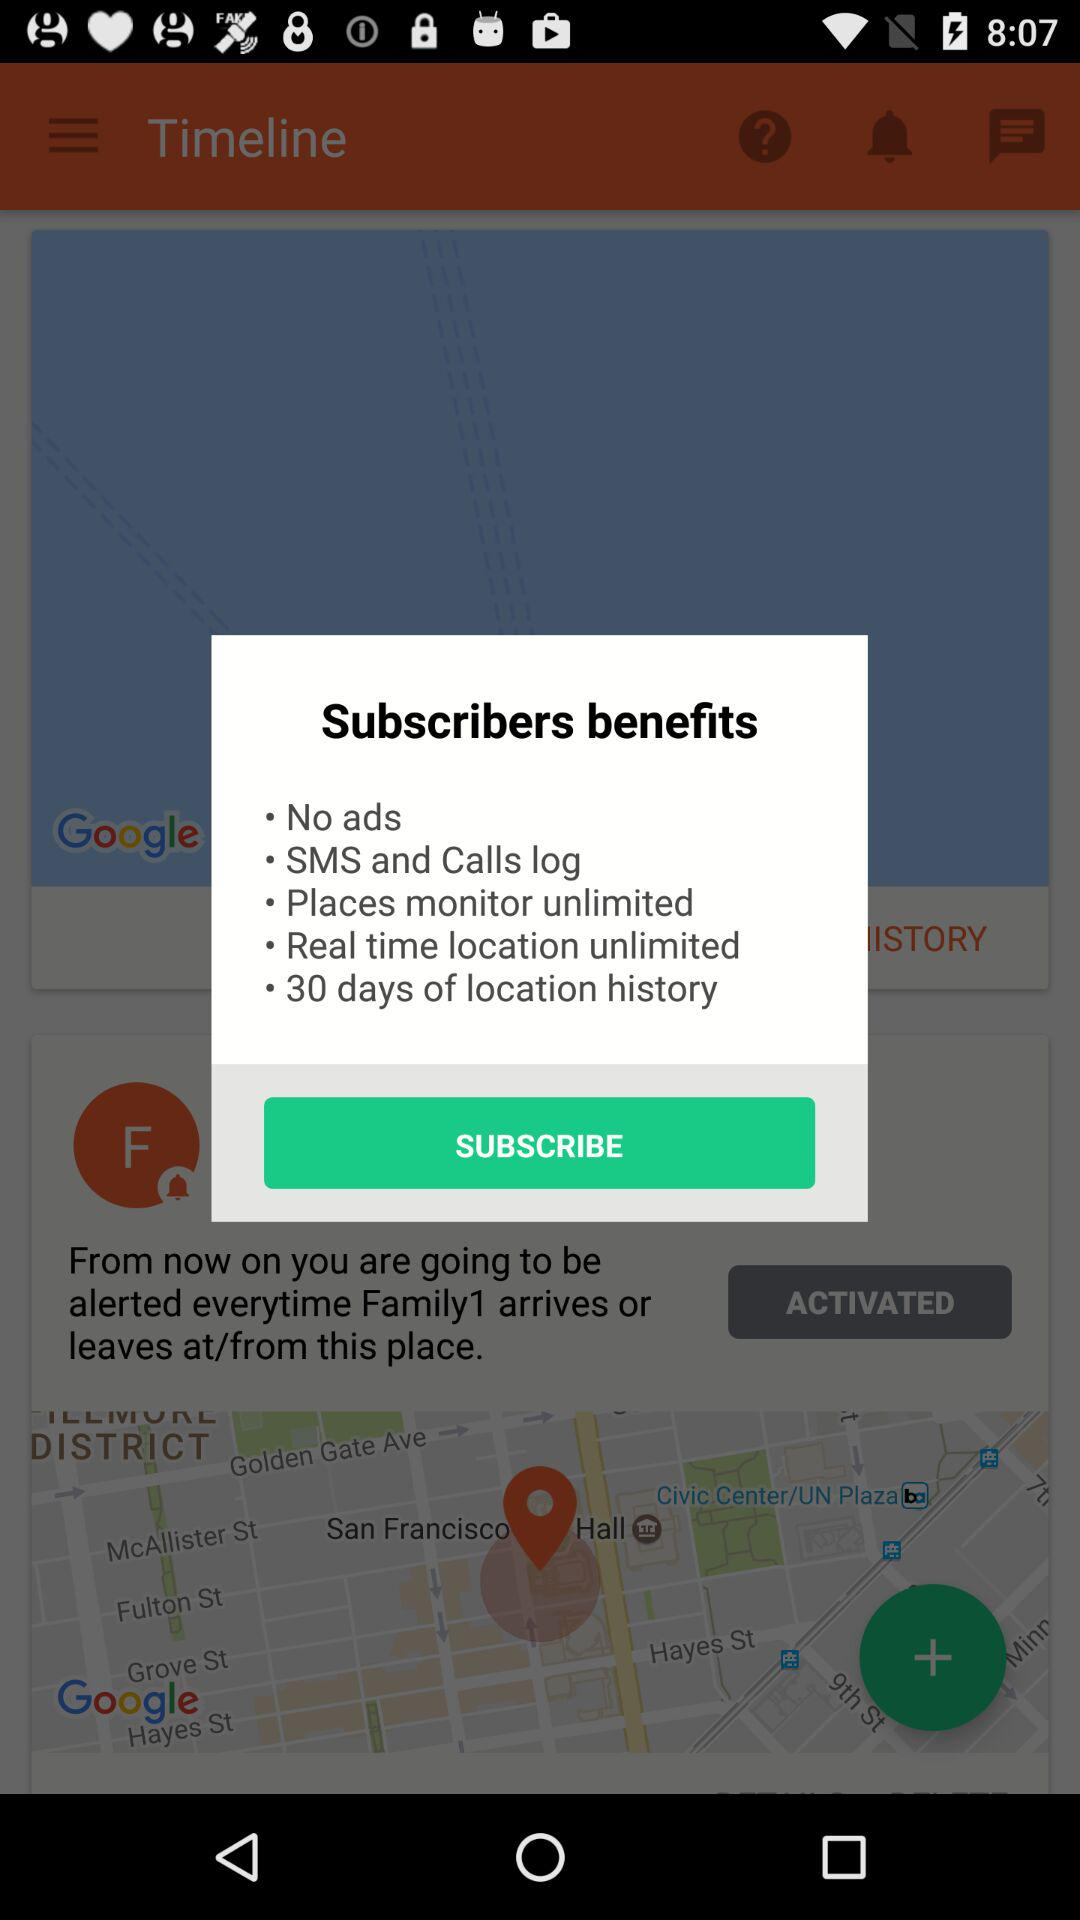How many benefits are mentioned?
Answer the question using a single word or phrase. 5 